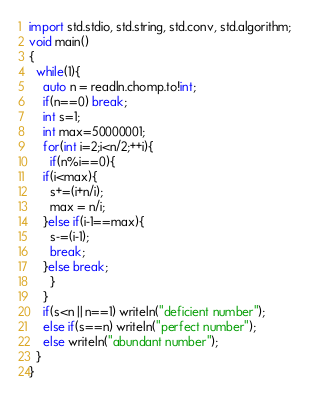<code> <loc_0><loc_0><loc_500><loc_500><_D_>import std.stdio, std.string, std.conv, std.algorithm;
void main()
{
  while(1){
    auto n = readln.chomp.to!int;
    if(n==0) break;
    int s=1;
    int max=50000001;
    for(int i=2;i<n/2;++i){
      if(n%i==0){
	if(i<max){
	  s+=(i+n/i);
	  max = n/i;
	}else if(i-1==max){
	  s-=(i-1);
	  break;
	}else break;
      }
    }
    if(s<n || n==1) writeln("deficient number");
    else if(s==n) writeln("perfect number");
    else writeln("abundant number");
  }
}</code> 